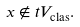<formula> <loc_0><loc_0><loc_500><loc_500>x \not \in t V _ { \text {clas} } .</formula> 